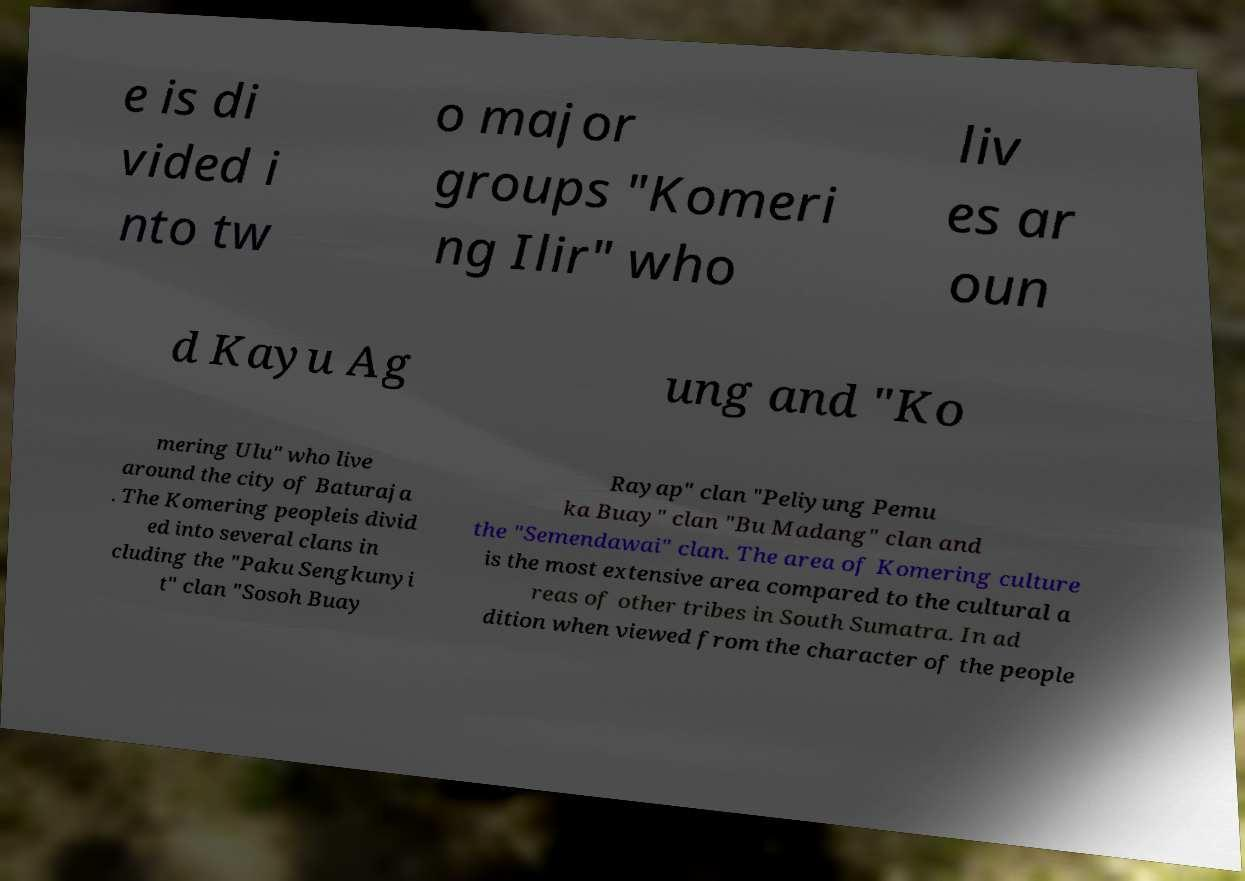Could you assist in decoding the text presented in this image and type it out clearly? e is di vided i nto tw o major groups "Komeri ng Ilir" who liv es ar oun d Kayu Ag ung and "Ko mering Ulu" who live around the city of Baturaja . The Komering peopleis divid ed into several clans in cluding the "Paku Sengkunyi t" clan "Sosoh Buay Rayap" clan "Peliyung Pemu ka Buay" clan "Bu Madang" clan and the "Semendawai" clan. The area of Komering culture is the most extensive area compared to the cultural a reas of other tribes in South Sumatra. In ad dition when viewed from the character of the people 